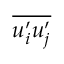Convert formula to latex. <formula><loc_0><loc_0><loc_500><loc_500>\overline { { u _ { i } ^ { \prime } u _ { j } ^ { \prime } } }</formula> 